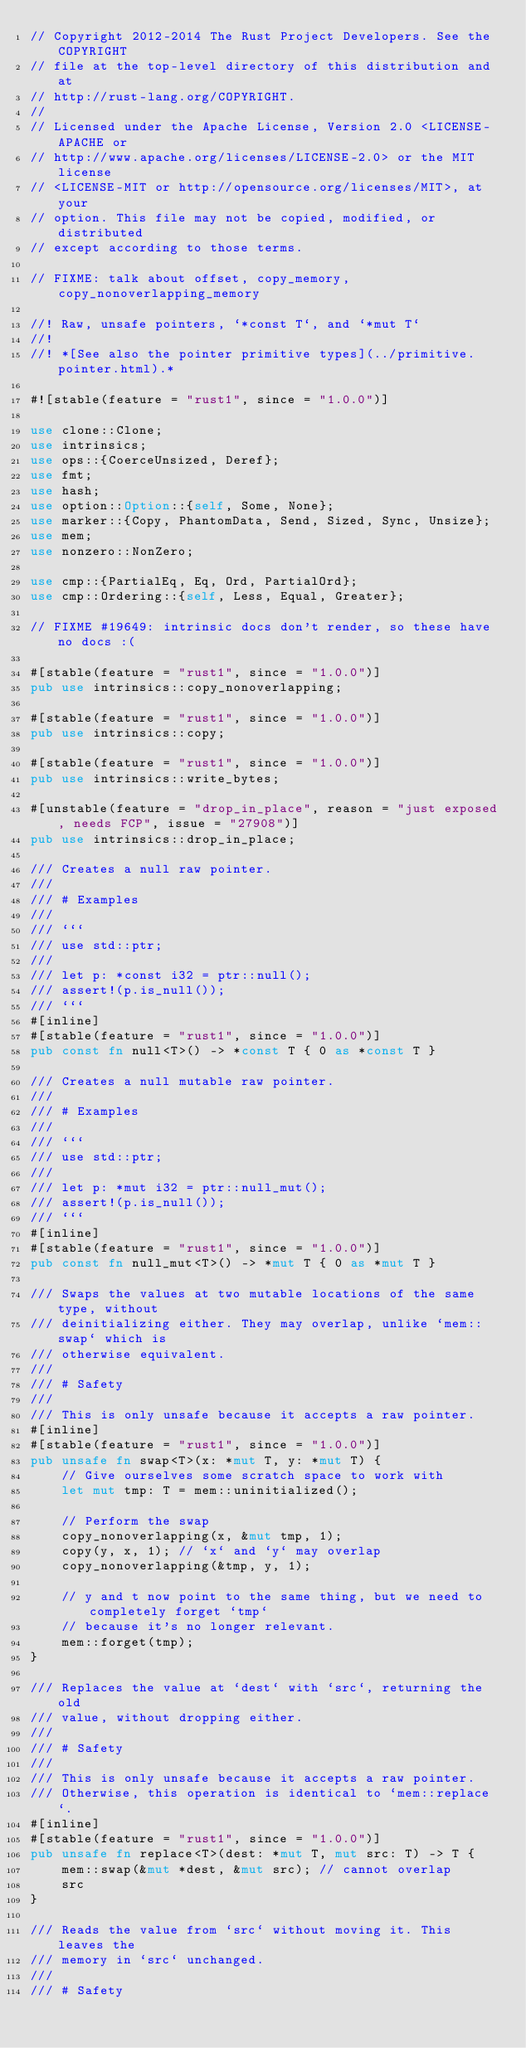Convert code to text. <code><loc_0><loc_0><loc_500><loc_500><_Rust_>// Copyright 2012-2014 The Rust Project Developers. See the COPYRIGHT
// file at the top-level directory of this distribution and at
// http://rust-lang.org/COPYRIGHT.
//
// Licensed under the Apache License, Version 2.0 <LICENSE-APACHE or
// http://www.apache.org/licenses/LICENSE-2.0> or the MIT license
// <LICENSE-MIT or http://opensource.org/licenses/MIT>, at your
// option. This file may not be copied, modified, or distributed
// except according to those terms.

// FIXME: talk about offset, copy_memory, copy_nonoverlapping_memory

//! Raw, unsafe pointers, `*const T`, and `*mut T`
//!
//! *[See also the pointer primitive types](../primitive.pointer.html).*

#![stable(feature = "rust1", since = "1.0.0")]

use clone::Clone;
use intrinsics;
use ops::{CoerceUnsized, Deref};
use fmt;
use hash;
use option::Option::{self, Some, None};
use marker::{Copy, PhantomData, Send, Sized, Sync, Unsize};
use mem;
use nonzero::NonZero;

use cmp::{PartialEq, Eq, Ord, PartialOrd};
use cmp::Ordering::{self, Less, Equal, Greater};

// FIXME #19649: intrinsic docs don't render, so these have no docs :(

#[stable(feature = "rust1", since = "1.0.0")]
pub use intrinsics::copy_nonoverlapping;

#[stable(feature = "rust1", since = "1.0.0")]
pub use intrinsics::copy;

#[stable(feature = "rust1", since = "1.0.0")]
pub use intrinsics::write_bytes;

#[unstable(feature = "drop_in_place", reason = "just exposed, needs FCP", issue = "27908")]
pub use intrinsics::drop_in_place;

/// Creates a null raw pointer.
///
/// # Examples
///
/// ```
/// use std::ptr;
///
/// let p: *const i32 = ptr::null();
/// assert!(p.is_null());
/// ```
#[inline]
#[stable(feature = "rust1", since = "1.0.0")]
pub const fn null<T>() -> *const T { 0 as *const T }

/// Creates a null mutable raw pointer.
///
/// # Examples
///
/// ```
/// use std::ptr;
///
/// let p: *mut i32 = ptr::null_mut();
/// assert!(p.is_null());
/// ```
#[inline]
#[stable(feature = "rust1", since = "1.0.0")]
pub const fn null_mut<T>() -> *mut T { 0 as *mut T }

/// Swaps the values at two mutable locations of the same type, without
/// deinitializing either. They may overlap, unlike `mem::swap` which is
/// otherwise equivalent.
///
/// # Safety
///
/// This is only unsafe because it accepts a raw pointer.
#[inline]
#[stable(feature = "rust1", since = "1.0.0")]
pub unsafe fn swap<T>(x: *mut T, y: *mut T) {
    // Give ourselves some scratch space to work with
    let mut tmp: T = mem::uninitialized();

    // Perform the swap
    copy_nonoverlapping(x, &mut tmp, 1);
    copy(y, x, 1); // `x` and `y` may overlap
    copy_nonoverlapping(&tmp, y, 1);

    // y and t now point to the same thing, but we need to completely forget `tmp`
    // because it's no longer relevant.
    mem::forget(tmp);
}

/// Replaces the value at `dest` with `src`, returning the old
/// value, without dropping either.
///
/// # Safety
///
/// This is only unsafe because it accepts a raw pointer.
/// Otherwise, this operation is identical to `mem::replace`.
#[inline]
#[stable(feature = "rust1", since = "1.0.0")]
pub unsafe fn replace<T>(dest: *mut T, mut src: T) -> T {
    mem::swap(&mut *dest, &mut src); // cannot overlap
    src
}

/// Reads the value from `src` without moving it. This leaves the
/// memory in `src` unchanged.
///
/// # Safety</code> 